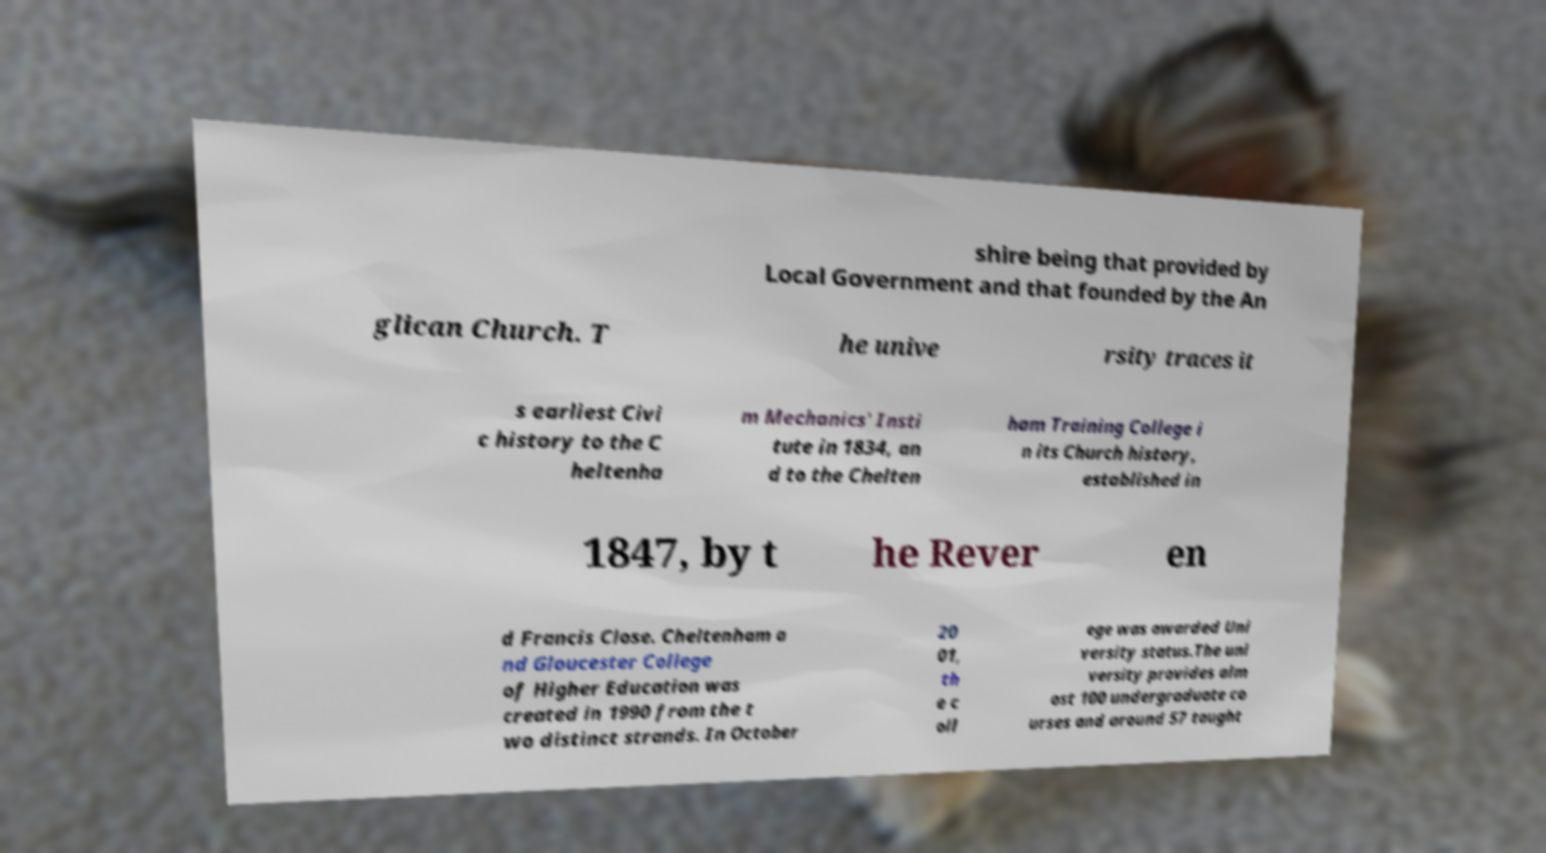What messages or text are displayed in this image? I need them in a readable, typed format. shire being that provided by Local Government and that founded by the An glican Church. T he unive rsity traces it s earliest Civi c history to the C heltenha m Mechanics' Insti tute in 1834, an d to the Chelten ham Training College i n its Church history, established in 1847, by t he Rever en d Francis Close. Cheltenham a nd Gloucester College of Higher Education was created in 1990 from the t wo distinct strands. In October 20 01, th e c oll ege was awarded Uni versity status.The uni versity provides alm ost 100 undergraduate co urses and around 57 taught 